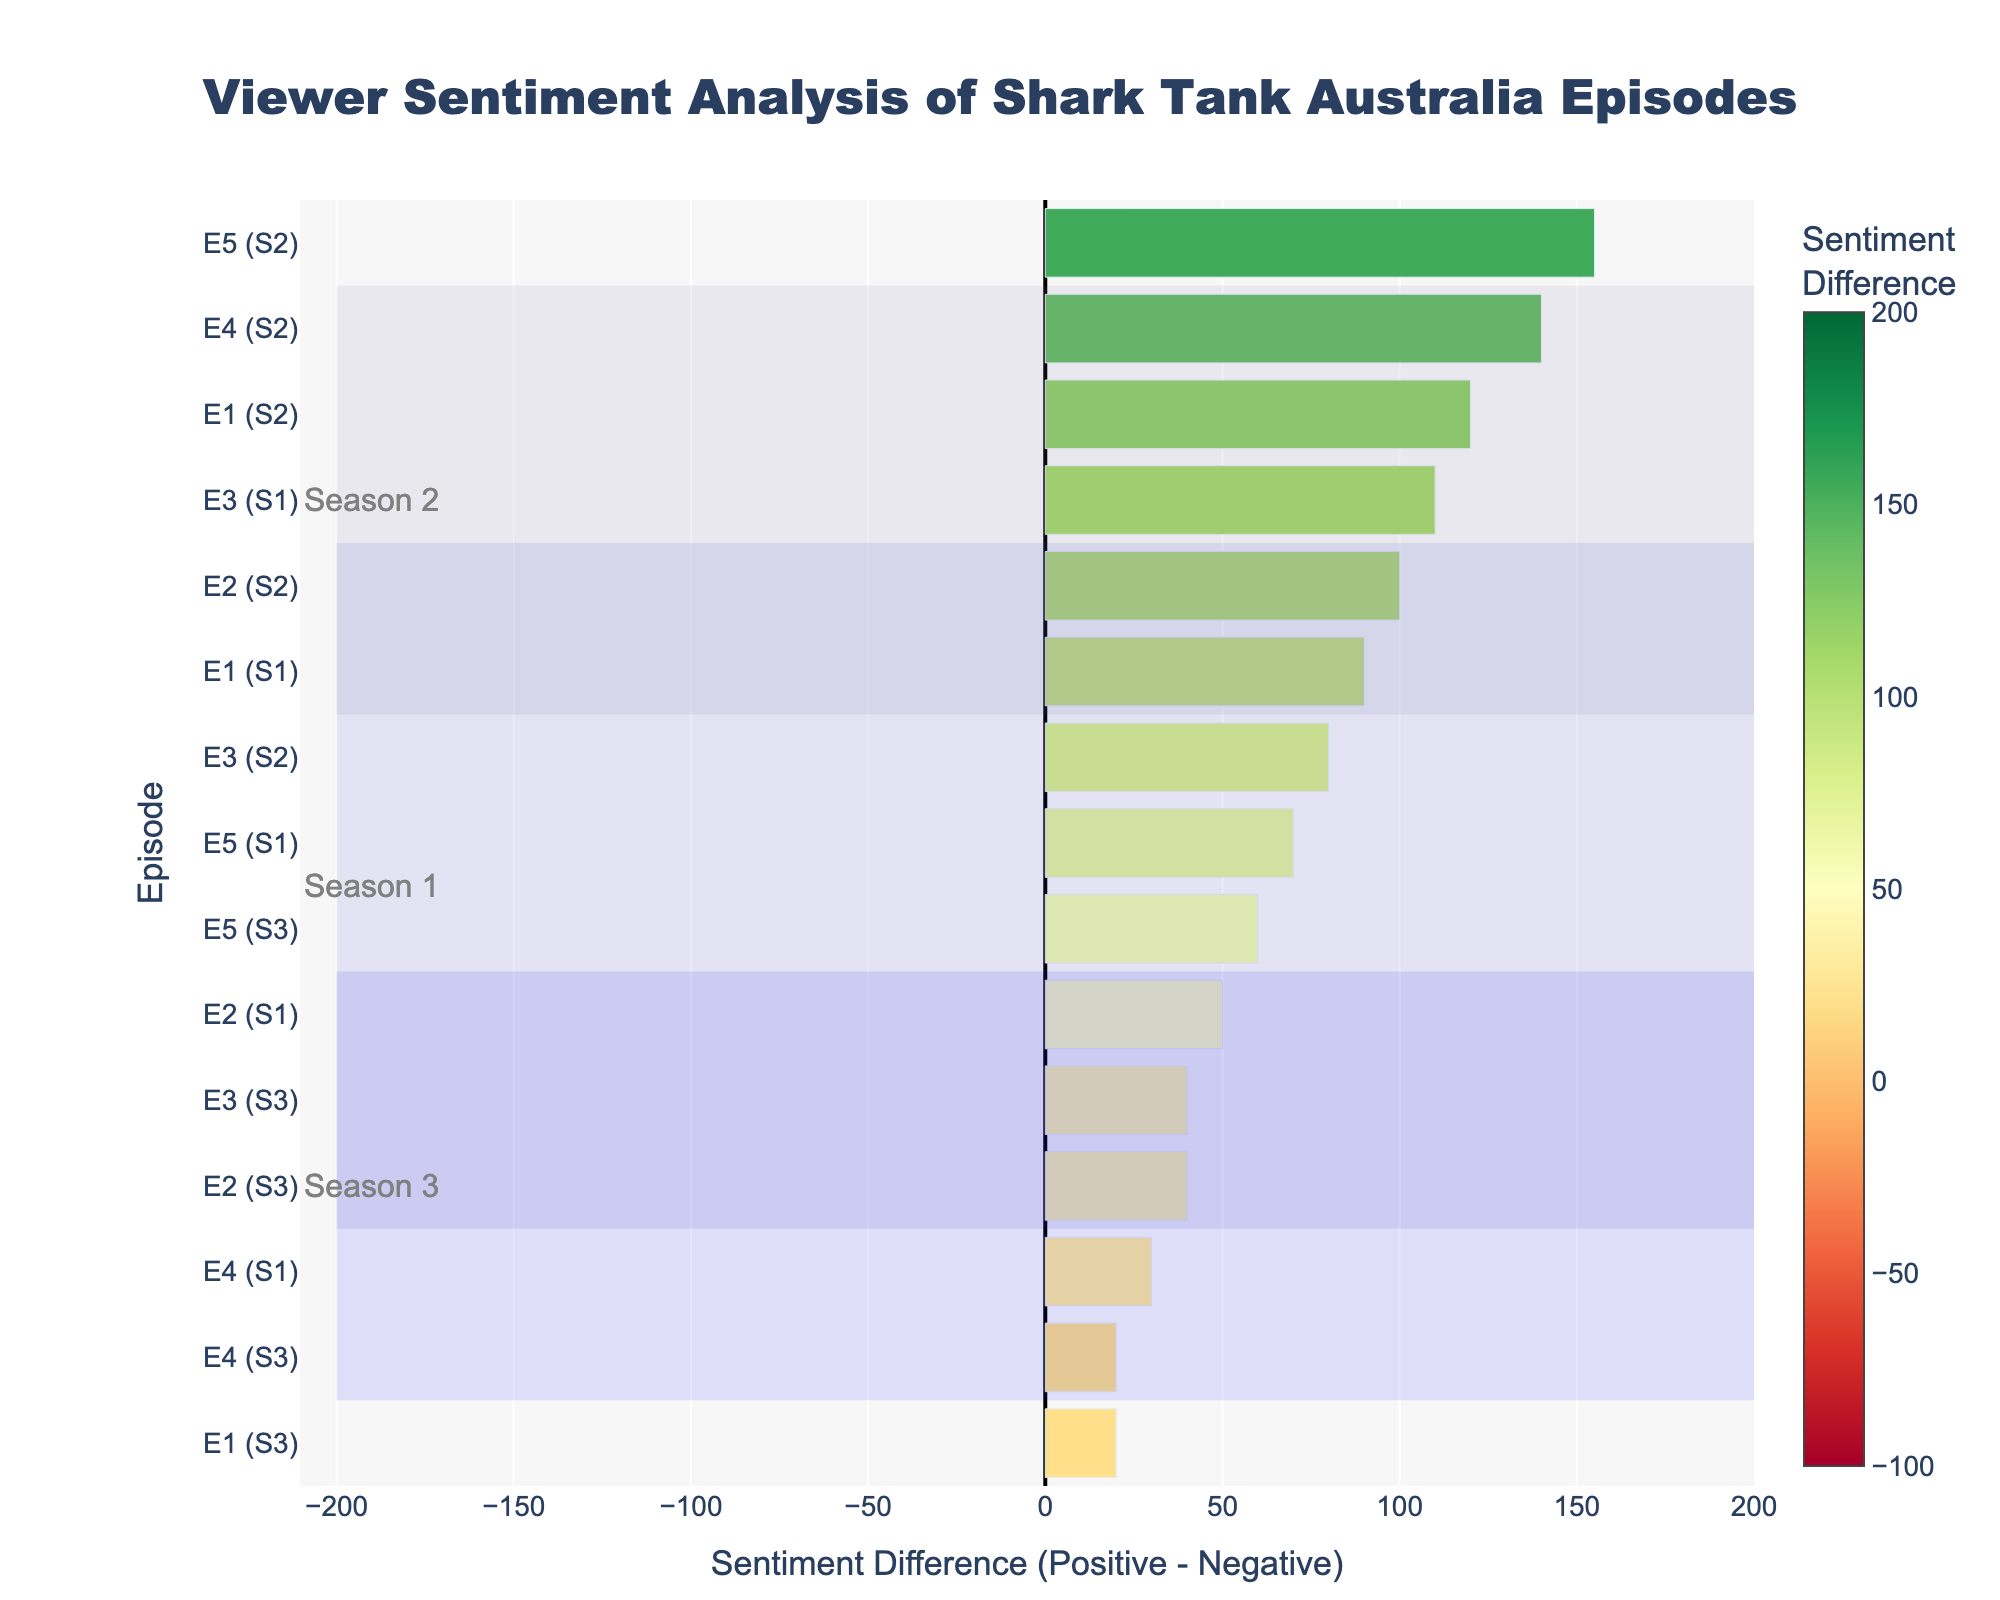Which season and episode has the highest positive sentiment value? Look for the highest positive sentiment value in the chart, which is 160. Correspond this value to the episode and season it belongs to, which is Episode 5, Season 2.
Answer: Episode 5, Season 2 Which season has the most balanced viewer sentiments overall? Compare the differences in sentiment for each season. Season 2 has consistently high sentiment differences, mostly positive, suggesting balanced positive feedback. Season 3 has more negative feedback, while Season 1 is more mixed.
Answer: Season 2 What is the difference in sentiment for Episode 4 of Season 3? Locate Episode 4 of Season 3 in the chart and read off the sentiment difference value, which is -20.
Answer: -20 Which episodes have more negative sentiment than positive sentiment? Identify episodes with negative values in the sentiment difference bars. These episodes are E4 (Season 3), E3 (Season 3), E2 (Season 3), and E1 (Season 3).
Answer: Episodes 1, 2, 3, 4 of Season 3 Does any episode in Season 2 have a negative sentiment difference? Examine the sentiment difference values for all episodes in Season 2. All values are positive, indicating no negative sentiment differences in Season 2.
Answer: No How much higher is the sentiment difference for Episode 5 in Season 2 compared to Episode 1 in Season 1? Subtract the sentiment difference for Episode 1 (Season 1) from Episode 5 (Season 2). Episode 5 has 155 and Episode 1 has 90, so the difference is 155 - 90 = 65.
Answer: 65 What color is associated with episodes that have the highest positive sentiment differences? Look at the color scale on the bar that represents high positive sentiment differences. These bars are green.
Answer: Green Which episode has the smallest positive sentiment difference? Find the smallest positive difference value, which is closest to zero but still positive. This value belongs to Episode 3 of Season 3, with a difference of 40.
Answer: Episode 3, Season 3 